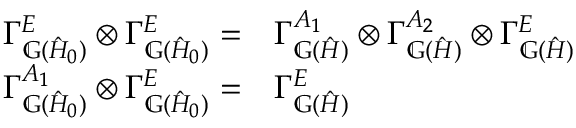Convert formula to latex. <formula><loc_0><loc_0><loc_500><loc_500>\begin{array} { r } { \begin{array} { r l } { \Gamma _ { \mathbb { G } ( \hat { H } _ { 0 } ) } ^ { E } \otimes \Gamma _ { \mathbb { G } ( \hat { H } _ { 0 } ) } ^ { E } = } & \Gamma _ { \mathbb { G } ( \hat { H } ) } ^ { A _ { 1 } } \otimes \Gamma _ { \mathbb { G } ( \hat { H } ) } ^ { A _ { 2 } } \otimes \Gamma _ { \mathbb { G } ( \hat { H } ) } ^ { E } } \\ { \Gamma _ { \mathbb { G } ( \hat { H } _ { 0 } ) } ^ { A _ { 1 } } \otimes \Gamma _ { \mathbb { G } ( \hat { H } _ { 0 } ) } ^ { E } = } & \Gamma _ { \mathbb { G } ( \hat { H } ) } ^ { E } } \end{array} } \end{array}</formula> 